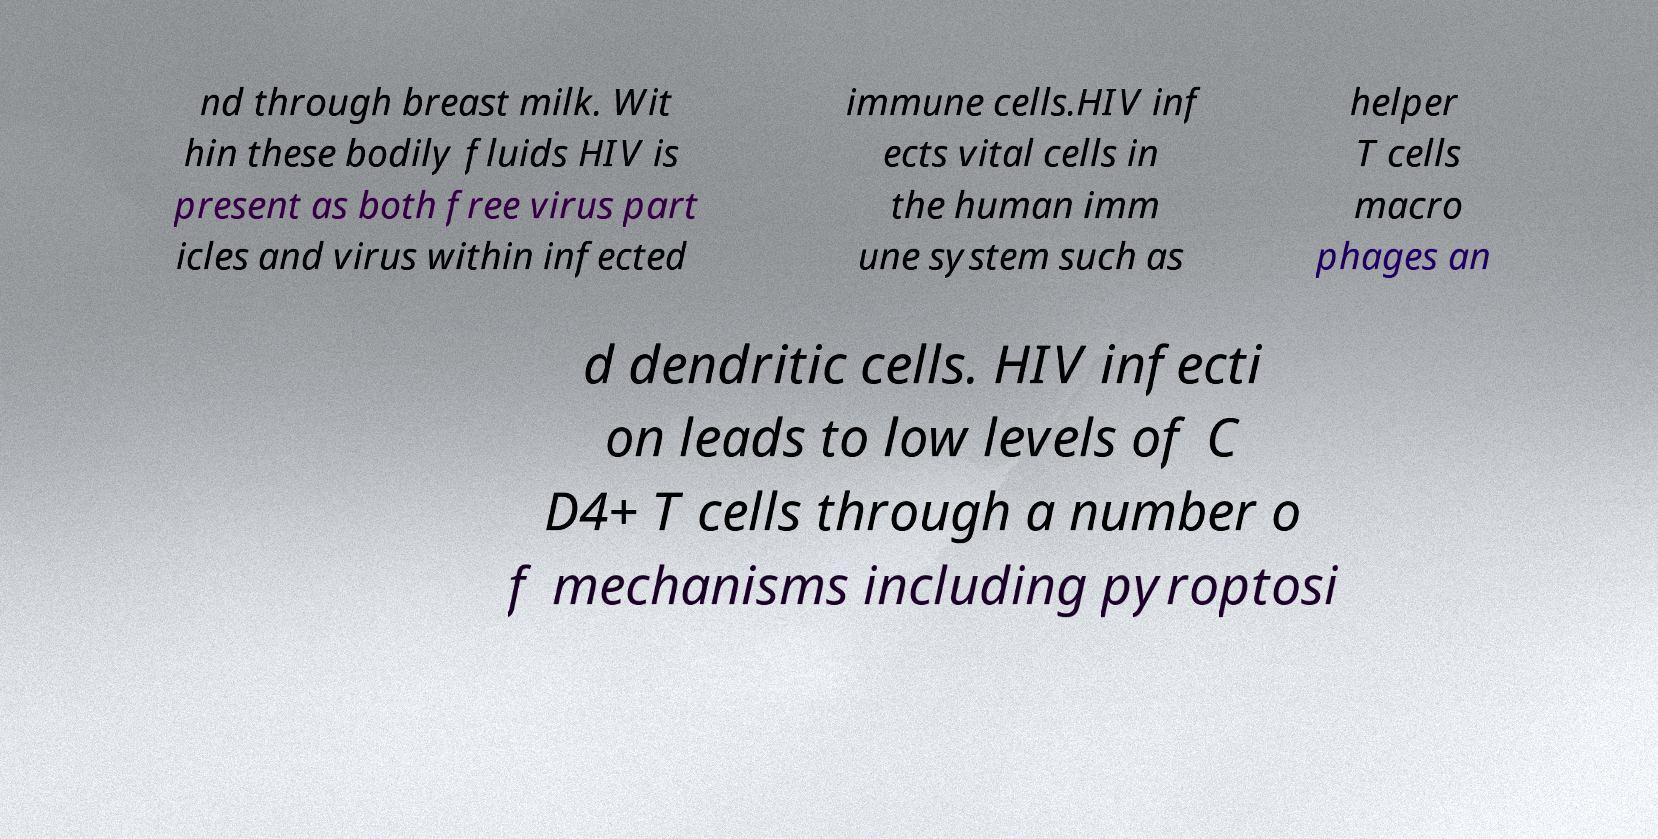Please read and relay the text visible in this image. What does it say? nd through breast milk. Wit hin these bodily fluids HIV is present as both free virus part icles and virus within infected immune cells.HIV inf ects vital cells in the human imm une system such as helper T cells macro phages an d dendritic cells. HIV infecti on leads to low levels of C D4+ T cells through a number o f mechanisms including pyroptosi 